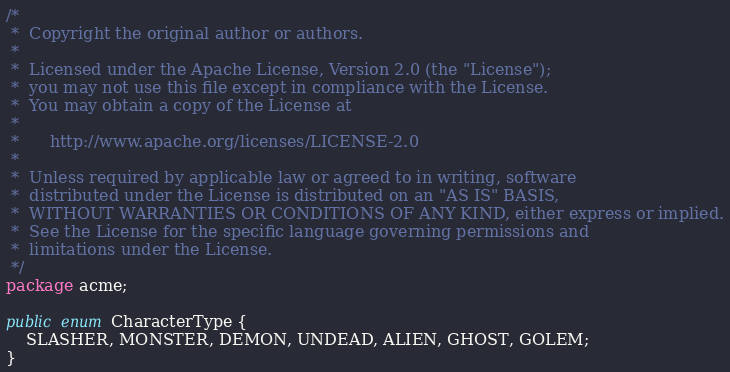Convert code to text. <code><loc_0><loc_0><loc_500><loc_500><_Java_>/*
 *  Copyright the original author or authors.
 *
 *  Licensed under the Apache License, Version 2.0 (the "License");
 *  you may not use this file except in compliance with the License.
 *  You may obtain a copy of the License at
 *
 *      http://www.apache.org/licenses/LICENSE-2.0
 *
 *  Unless required by applicable law or agreed to in writing, software
 *  distributed under the License is distributed on an "AS IS" BASIS,
 *  WITHOUT WARRANTIES OR CONDITIONS OF ANY KIND, either express or implied.
 *  See the License for the specific language governing permissions and
 *  limitations under the License.
 */
package acme;

public enum CharacterType {
    SLASHER, MONSTER, DEMON, UNDEAD, ALIEN, GHOST, GOLEM;
}
</code> 